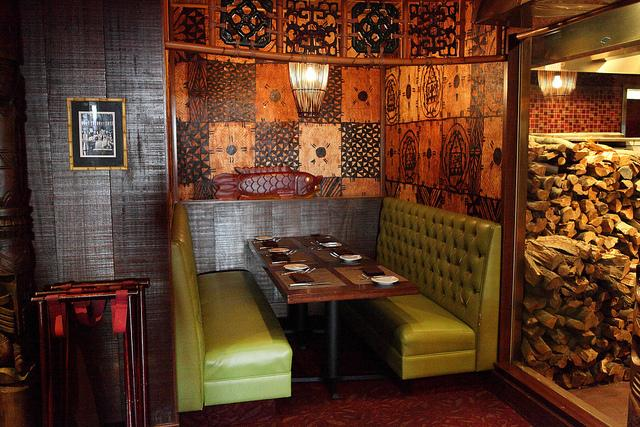How many people could fit comfortably in each booth? Please explain your reasoning. four. This would give people room to move their arms as they eat 